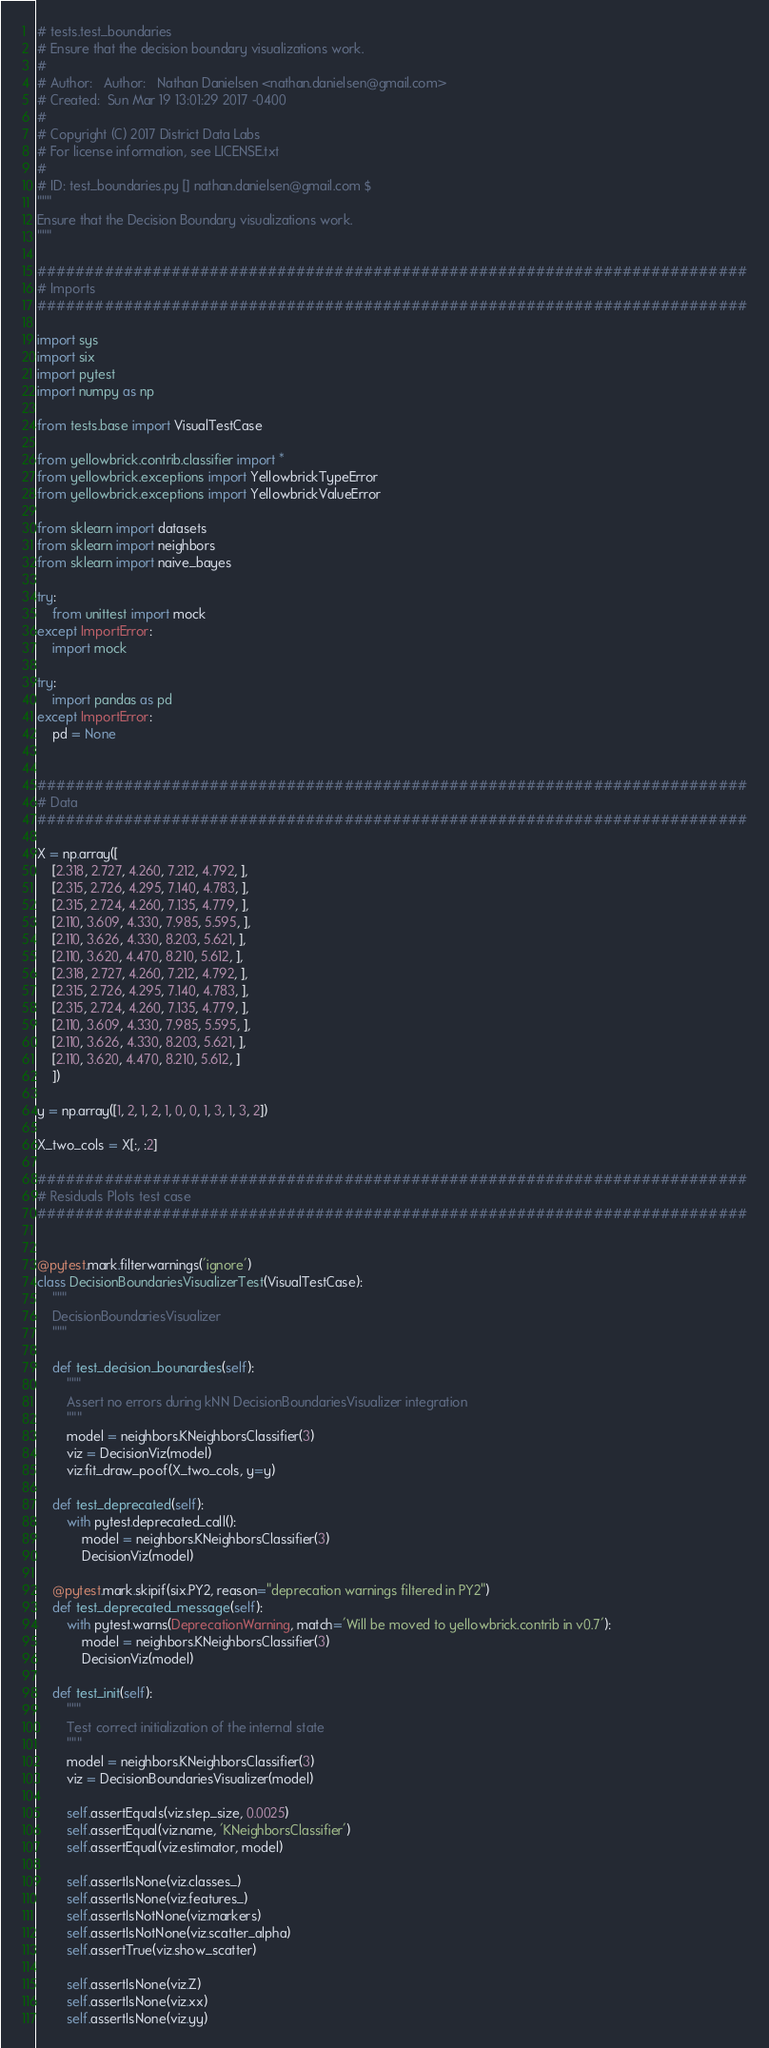<code> <loc_0><loc_0><loc_500><loc_500><_Python_># tests.test_boundaries
# Ensure that the decision boundary visualizations work.
#
# Author:   Author:   Nathan Danielsen <nathan.danielsen@gmail.com>
# Created:  Sun Mar 19 13:01:29 2017 -0400
#
# Copyright (C) 2017 District Data Labs
# For license information, see LICENSE.txt
#
# ID: test_boundaries.py [] nathan.danielsen@gmail.com $
"""
Ensure that the Decision Boundary visualizations work.
"""

##########################################################################
# Imports
##########################################################################

import sys
import six
import pytest
import numpy as np

from tests.base import VisualTestCase

from yellowbrick.contrib.classifier import *
from yellowbrick.exceptions import YellowbrickTypeError
from yellowbrick.exceptions import YellowbrickValueError

from sklearn import datasets
from sklearn import neighbors
from sklearn import naive_bayes

try:
    from unittest import mock
except ImportError:
    import mock

try:
    import pandas as pd
except ImportError:
    pd = None


##########################################################################
# Data
##########################################################################

X = np.array([
    [2.318, 2.727, 4.260, 7.212, 4.792, ],
    [2.315, 2.726, 4.295, 7.140, 4.783, ],
    [2.315, 2.724, 4.260, 7.135, 4.779, ],
    [2.110, 3.609, 4.330, 7.985, 5.595, ],
    [2.110, 3.626, 4.330, 8.203, 5.621, ],
    [2.110, 3.620, 4.470, 8.210, 5.612, ],
    [2.318, 2.727, 4.260, 7.212, 4.792, ],
    [2.315, 2.726, 4.295, 7.140, 4.783, ],
    [2.315, 2.724, 4.260, 7.135, 4.779, ],
    [2.110, 3.609, 4.330, 7.985, 5.595, ],
    [2.110, 3.626, 4.330, 8.203, 5.621, ],
    [2.110, 3.620, 4.470, 8.210, 5.612, ]
    ])

y = np.array([1, 2, 1, 2, 1, 0, 0, 1, 3, 1, 3, 2])

X_two_cols = X[:, :2]

##########################################################################
# Residuals Plots test case
##########################################################################


@pytest.mark.filterwarnings('ignore')
class DecisionBoundariesVisualizerTest(VisualTestCase):
    """
    DecisionBoundariesVisualizer
    """

    def test_decision_bounardies(self):
        """
        Assert no errors during kNN DecisionBoundariesVisualizer integration
        """
        model = neighbors.KNeighborsClassifier(3)
        viz = DecisionViz(model)
        viz.fit_draw_poof(X_two_cols, y=y)

    def test_deprecated(self):
        with pytest.deprecated_call():
            model = neighbors.KNeighborsClassifier(3)
            DecisionViz(model)

    @pytest.mark.skipif(six.PY2, reason="deprecation warnings filtered in PY2")
    def test_deprecated_message(self):
        with pytest.warns(DeprecationWarning, match='Will be moved to yellowbrick.contrib in v0.7'):
            model = neighbors.KNeighborsClassifier(3)
            DecisionViz(model)

    def test_init(self):
        """
        Test correct initialization of the internal state
        """
        model = neighbors.KNeighborsClassifier(3)
        viz = DecisionBoundariesVisualizer(model)

        self.assertEquals(viz.step_size, 0.0025)
        self.assertEqual(viz.name, 'KNeighborsClassifier')
        self.assertEqual(viz.estimator, model)

        self.assertIsNone(viz.classes_)
        self.assertIsNone(viz.features_)
        self.assertIsNotNone(viz.markers)
        self.assertIsNotNone(viz.scatter_alpha)
        self.assertTrue(viz.show_scatter)

        self.assertIsNone(viz.Z)
        self.assertIsNone(viz.xx)
        self.assertIsNone(viz.yy)</code> 